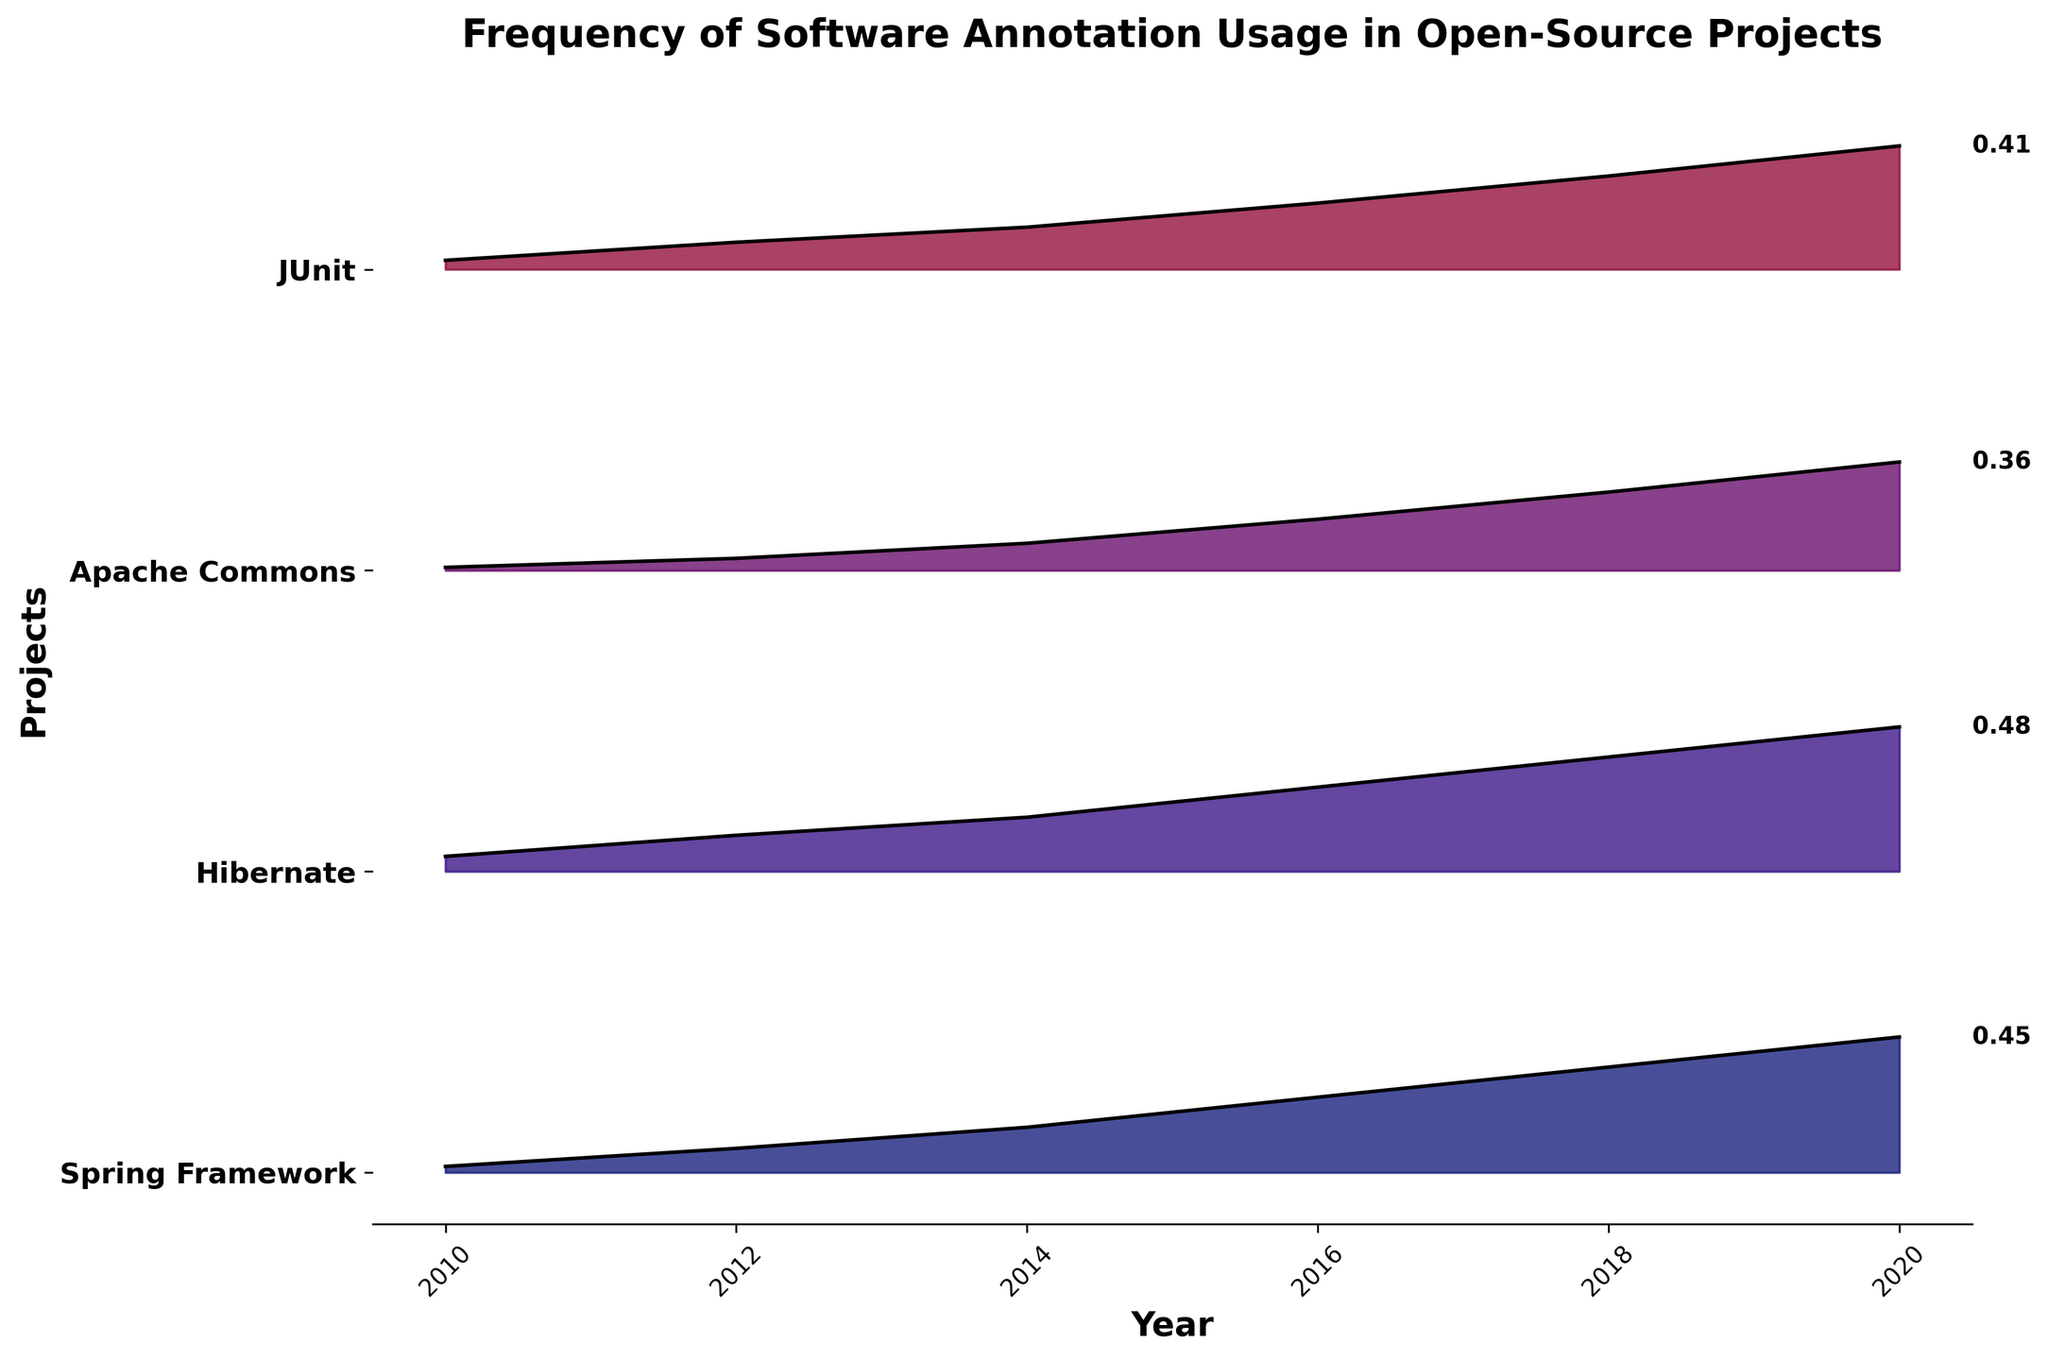what is the title of the figure? The title of the figure is located at the top and helps to understand the focus of the plot. In this case, the title text is clearly shown as "Frequency of Software Annotation Usage in Open-Source Projects".
Answer: Frequency of Software Annotation Usage in Open-Source Projects Which year has the highest annotation frequency for Hibernate? Locate the line corresponding to Hibernate and observe where the peak is highest for the year axis. In this plot, the peak is highest in 2020.
Answer: 2020 What's the frequency value for the Apache Commons project in 2018? Identify the ridge corresponding to the Apache Commons project and find the height of the line segment over the year 2018. The frequency value indicated next to the line is 0.26.
Answer: 0.26 How many unique open-source projects are shown in the plot? Count the number of different ridges, each representing a unique project. There are four distinct ridges, indicating four open-source projects.
Answer: 4 Between 2014 and 2016, did the annotation frequency for Spring Framework increase or decrease? Compare the height of the curves for the Spring Framework from 2014 to 2016. The frequency increase is observed as the height increases from 0.15 to 0.25.
Answer: Increase What’s the average annotation frequency of JUnit across all the years shown? Add up the frequency values of JUnit for the years 2010, 2012, 2014, 2016, 2018, and 2020. Divide by the number of years. (0.03 + 0.09 + 0.14 + 0.22 + 0.31 + 0.41) / 6 = 1.2 / 6 = 0.2
Answer: 0.2 Which project has the lowest annotation frequency in 2020? Compare the frequency values for all projects in 2020 by observing the y-values. Apache Commons has the lowest frequency of 0.36.
Answer: Apache Commons By how much did the annotation frequency of Hibernate change from 2016 to 2018? Subtract the annotation frequency of Hibernate in 2016 from its frequency in 2018. 0.38 - 0.28 = 0.10
Answer: 0.10 Which project shows the steepest increase in annotation frequency between any two consecutive years? Compare the steepness of lines by visually inspecting the differences between the frequencies over consecutive years. Spring Framework from 2010 to 2012 shows a steep increase from 0.02 to 0.08.
Answer: Spring Framework 